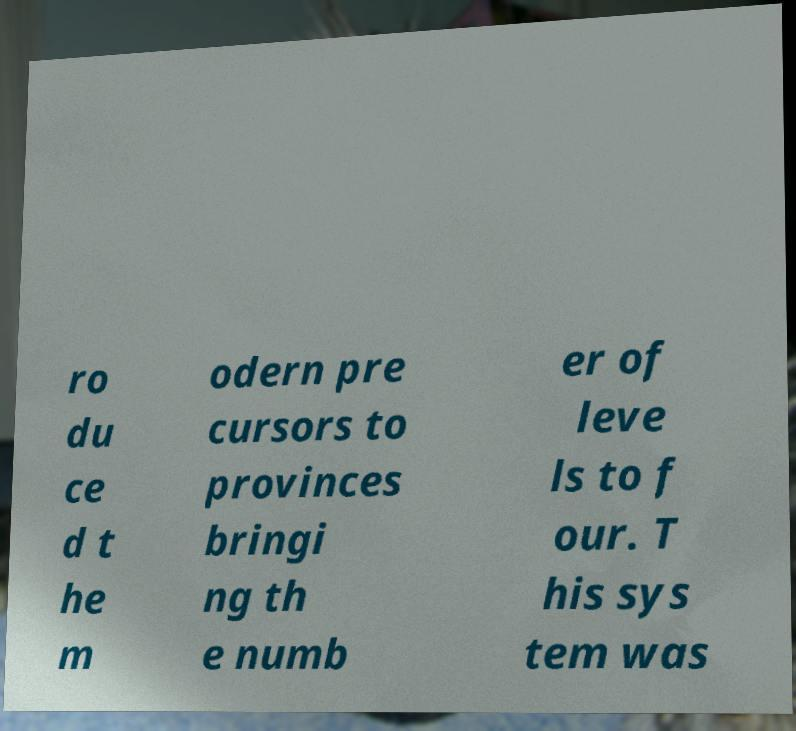Could you assist in decoding the text presented in this image and type it out clearly? ro du ce d t he m odern pre cursors to provinces bringi ng th e numb er of leve ls to f our. T his sys tem was 